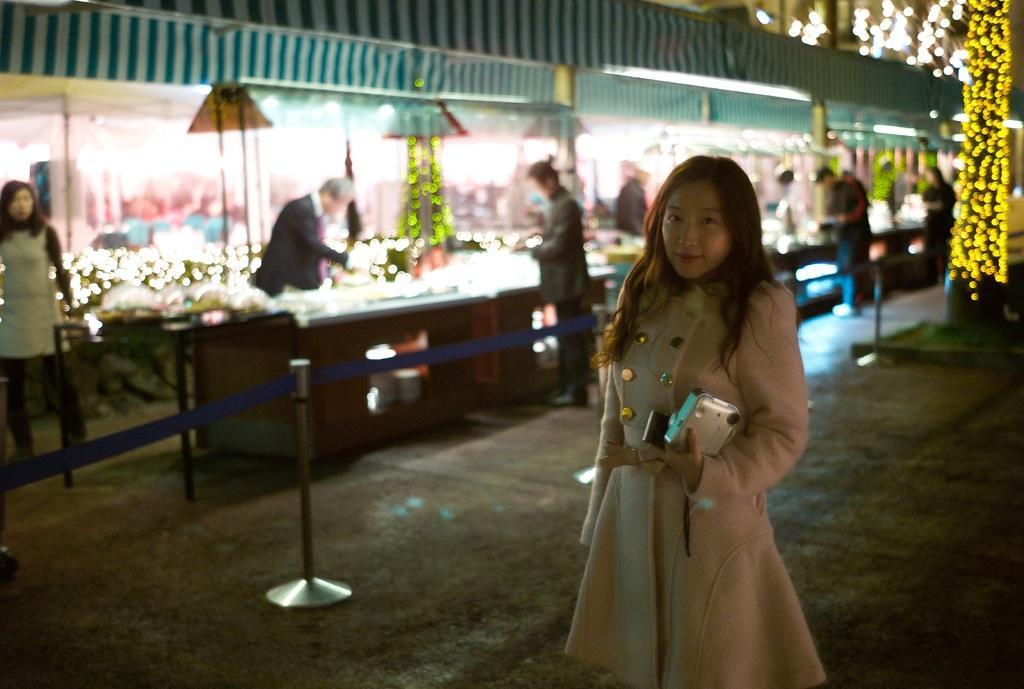Describe this image in one or two sentences. a person is standing holding a purse in her hand. at the left behind her there are stalls and people are standing there. at the back there is a pole on which there are yellow lights. it is the night time. 